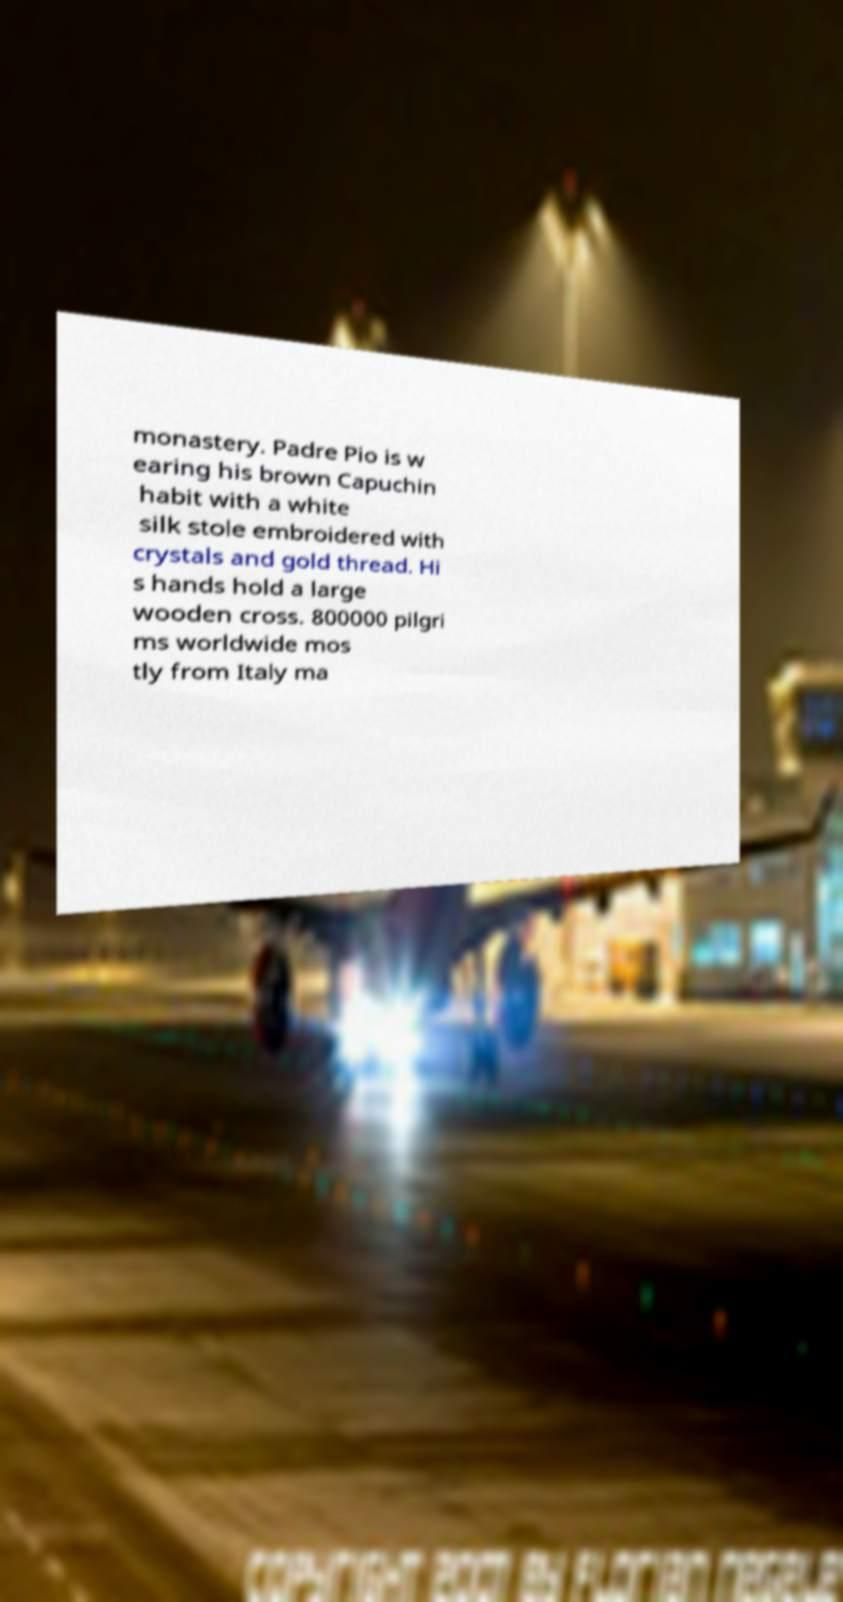Can you accurately transcribe the text from the provided image for me? monastery. Padre Pio is w earing his brown Capuchin habit with a white silk stole embroidered with crystals and gold thread. Hi s hands hold a large wooden cross. 800000 pilgri ms worldwide mos tly from Italy ma 